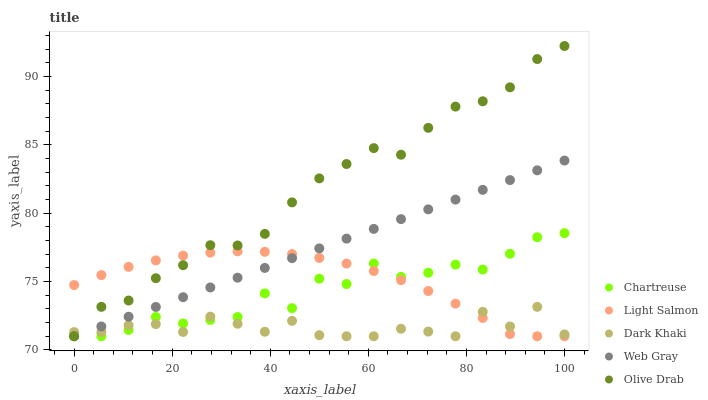Does Dark Khaki have the minimum area under the curve?
Answer yes or no. Yes. Does Olive Drab have the maximum area under the curve?
Answer yes or no. Yes. Does Chartreuse have the minimum area under the curve?
Answer yes or no. No. Does Chartreuse have the maximum area under the curve?
Answer yes or no. No. Is Web Gray the smoothest?
Answer yes or no. Yes. Is Chartreuse the roughest?
Answer yes or no. Yes. Is Chartreuse the smoothest?
Answer yes or no. No. Is Web Gray the roughest?
Answer yes or no. No. Does Dark Khaki have the lowest value?
Answer yes or no. Yes. Does Olive Drab have the highest value?
Answer yes or no. Yes. Does Chartreuse have the highest value?
Answer yes or no. No. Does Dark Khaki intersect Olive Drab?
Answer yes or no. Yes. Is Dark Khaki less than Olive Drab?
Answer yes or no. No. Is Dark Khaki greater than Olive Drab?
Answer yes or no. No. 